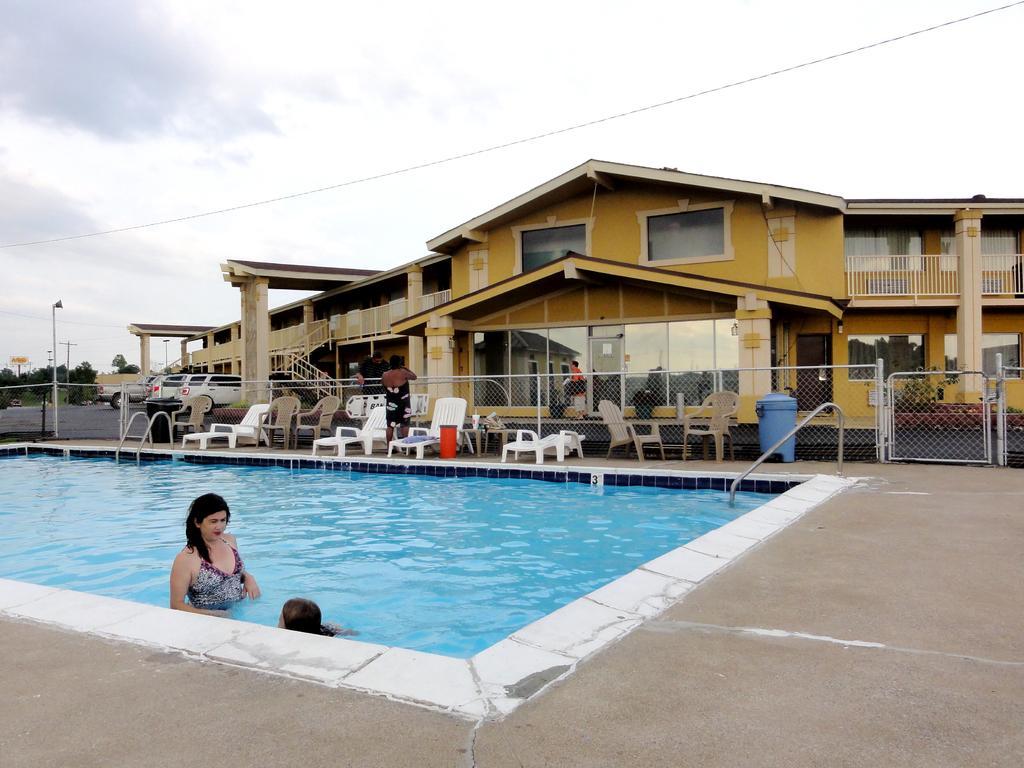Please provide a concise description of this image. In this image we can see a swimming pool. There are two ladies. In the background of the image there is house. There are chairs, cars, trees. At the top of the image there is sky and clouds. 